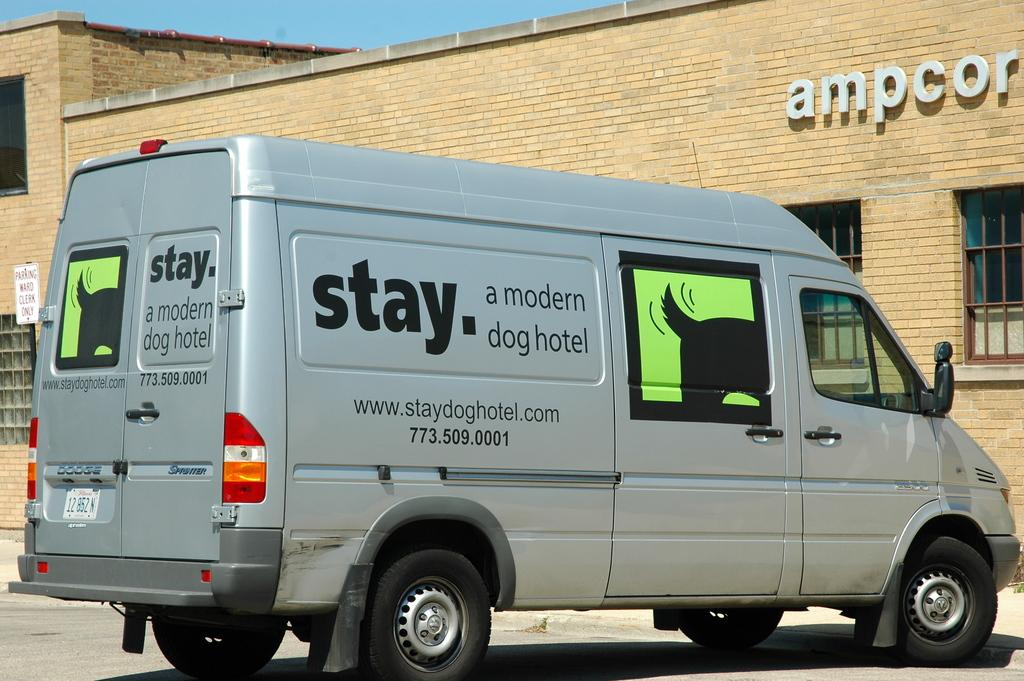<image>
Offer a succinct explanation of the picture presented. A silver van has the word stay on it in large, black print. 